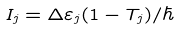Convert formula to latex. <formula><loc_0><loc_0><loc_500><loc_500>I _ { j } = \Delta \varepsilon _ { j } ( 1 - T _ { j } ) / \hbar</formula> 